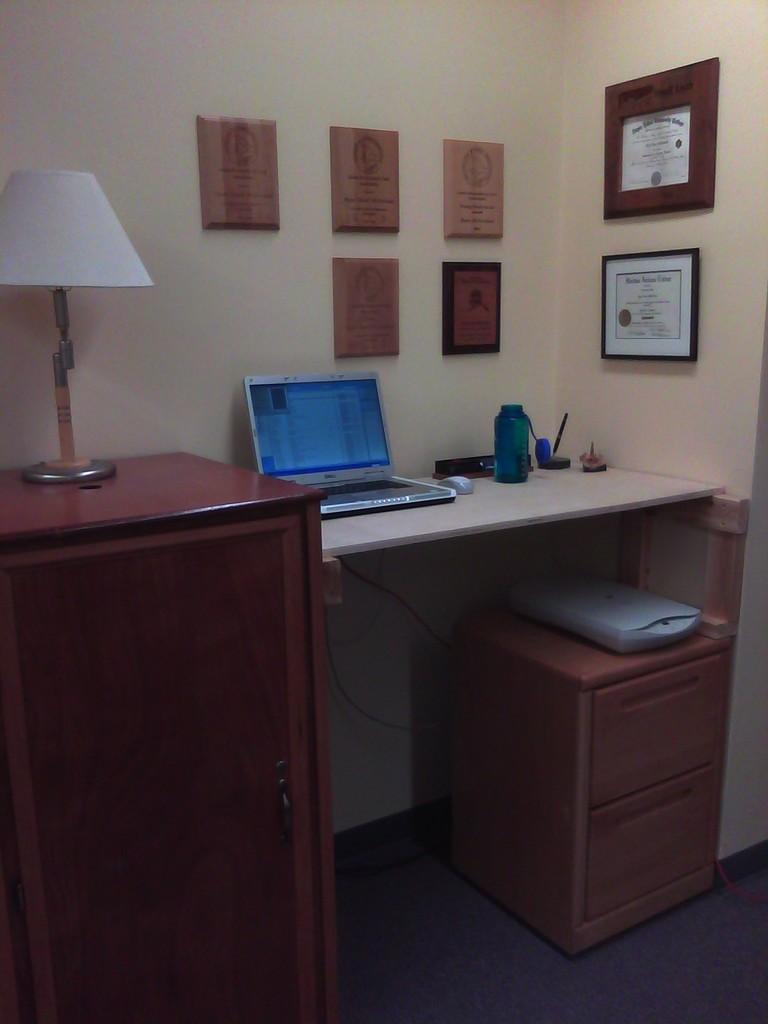Could you give a brief overview of what you see in this image? This image is clicked in a room. Towards the wall there is a table and desk. On the table there is a laptop, a bottle, a mouse and some pens. On the desk there is a lamp and some frames are attached to the wall. 